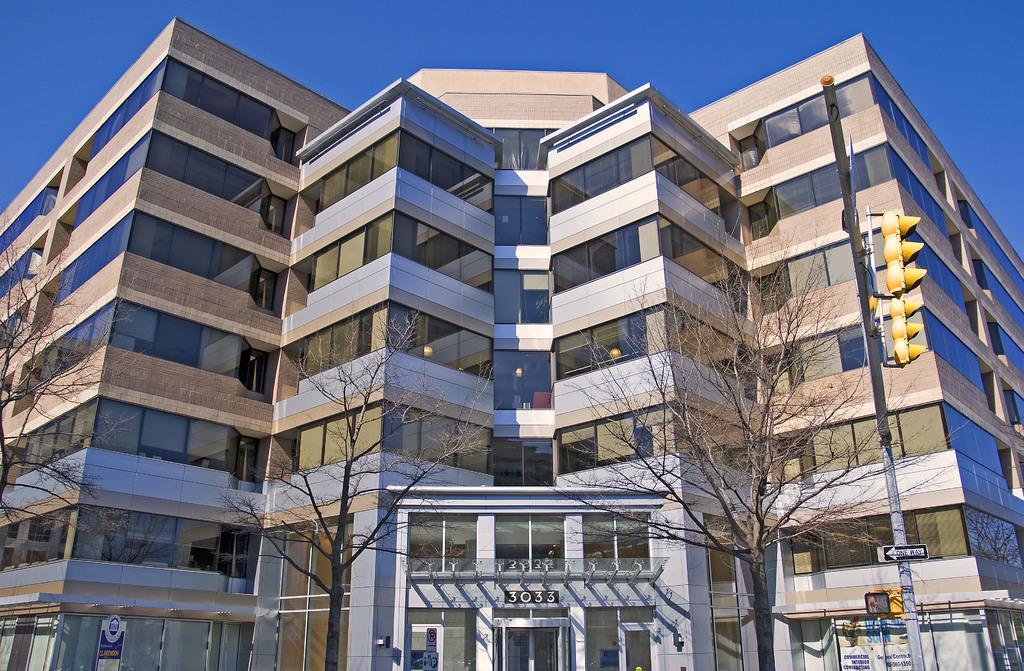Describe this image in one or two sentences. This picture shows buildings and we see trees and a blue sky and a pole with traffic signal lights. 